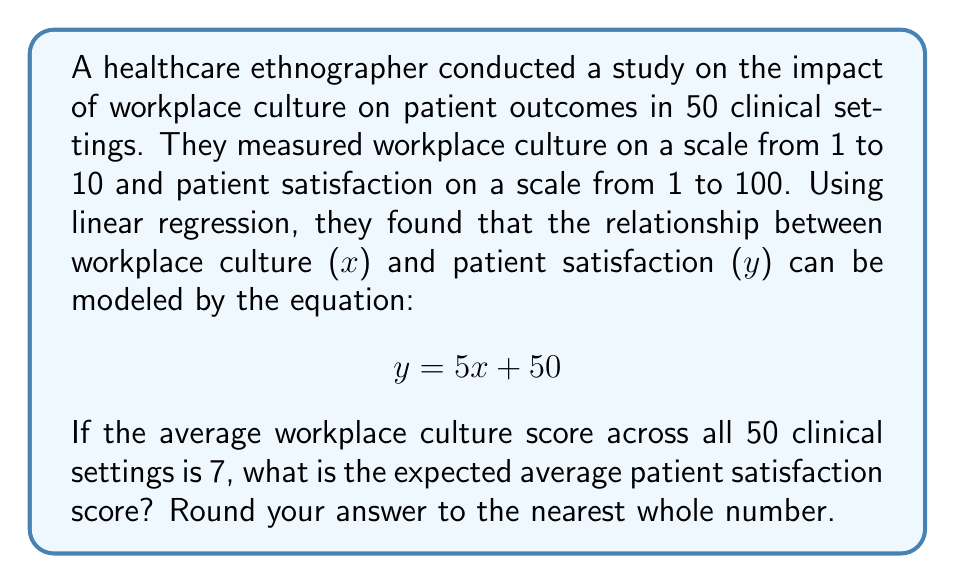Can you solve this math problem? To solve this problem, we'll follow these steps:

1) We're given the linear regression equation:
   $$y = 5x + 50$$
   where $x$ is the workplace culture score and $y$ is the patient satisfaction score.

2) We're told that the average workplace culture score ($x$) across all 50 clinical settings is 7.

3) To find the expected average patient satisfaction score, we need to substitute $x = 7$ into our equation:

   $$y = 5(7) + 50$$

4) Let's calculate:
   $$y = 35 + 50 = 85$$

5) The question asks for the answer rounded to the nearest whole number. Since 85 is already a whole number, no rounding is necessary.

Therefore, the expected average patient satisfaction score is 85.
Answer: 85 